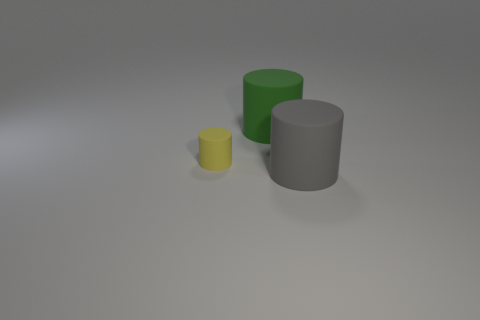What number of things are either objects behind the tiny yellow cylinder or large rubber things on the left side of the gray object?
Provide a short and direct response. 1. Does the cylinder that is in front of the yellow cylinder have the same size as the small yellow matte cylinder?
Your response must be concise. No. The large matte object left of the large gray thing is what color?
Your response must be concise. Green. The other big matte thing that is the same shape as the gray rubber object is what color?
Offer a very short reply. Green. How many big gray objects are right of the rubber cylinder that is to the left of the large rubber thing that is behind the large gray rubber object?
Make the answer very short. 1. Is the number of big gray rubber things that are to the right of the small yellow thing less than the number of large green cylinders?
Offer a very short reply. No. What is the size of the green matte object that is the same shape as the yellow matte object?
Keep it short and to the point. Large. What number of cylinders are the same material as the big gray object?
Your answer should be compact. 2. Do the big thing that is behind the tiny yellow thing and the big gray cylinder have the same material?
Your answer should be compact. Yes. Are there an equal number of yellow matte things that are on the right side of the big gray matte cylinder and large brown cubes?
Provide a succinct answer. Yes. 